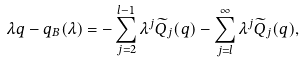Convert formula to latex. <formula><loc_0><loc_0><loc_500><loc_500>{ \lambda q } - { q } _ { B } ( \lambda ) = - \sum _ { j = 2 } ^ { l - 1 } \lambda ^ { j } { \widetilde { Q } _ { j } ( q ) } - \sum _ { j = l } ^ { \infty } \lambda ^ { j } { \widetilde { Q } _ { j } ( q ) } ,</formula> 